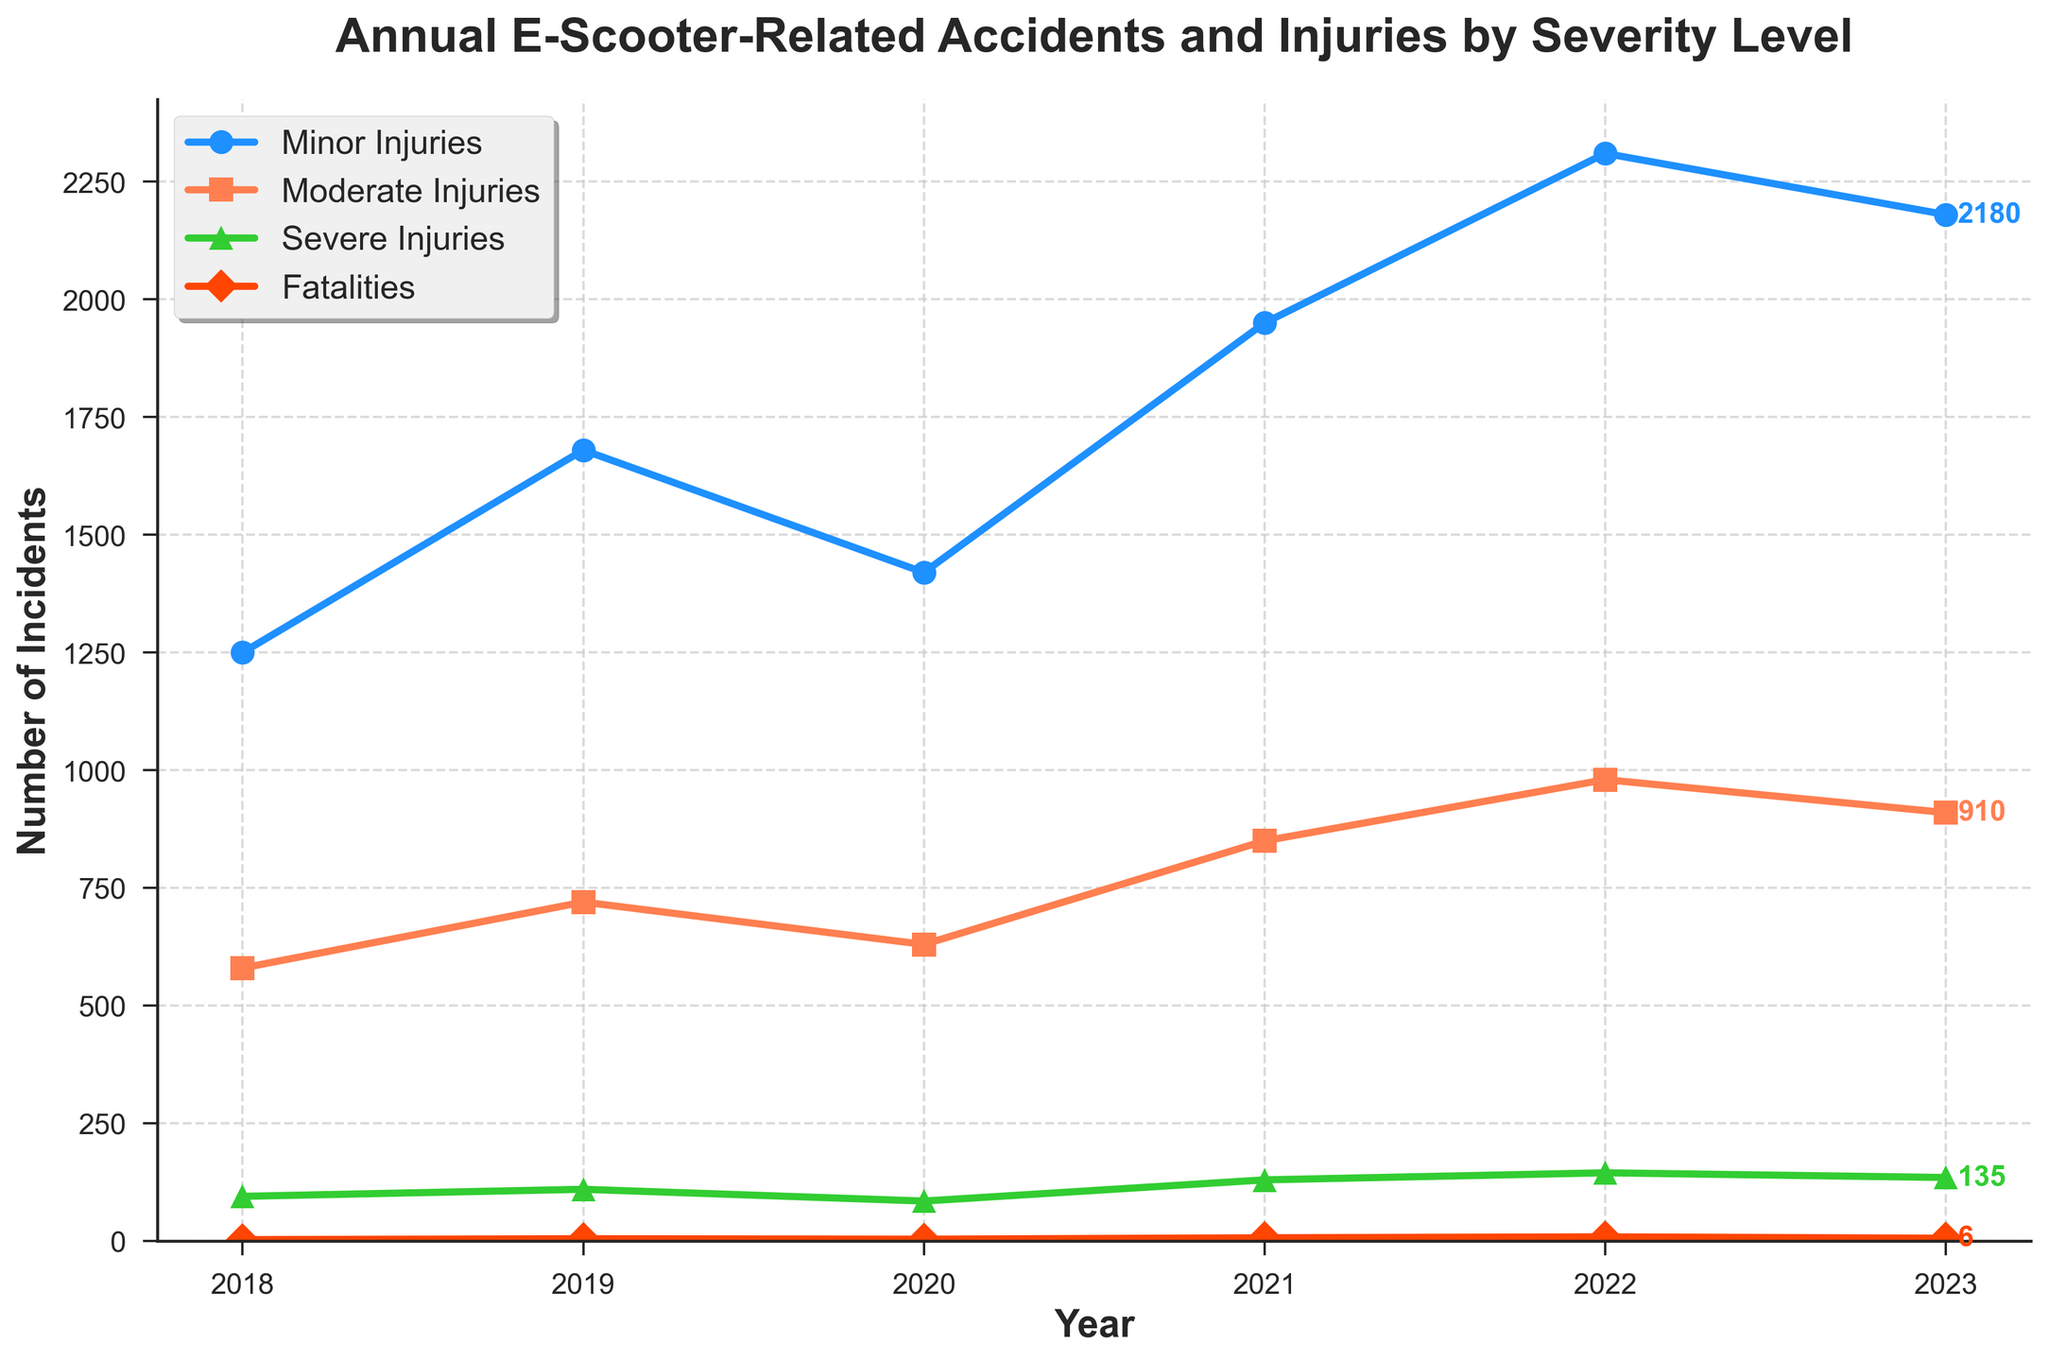What is the trend of Minor Injuries from 2018 to 2023? The figure shows a generally increasing trend in Minor Injuries from 1250 in 2018 to 2310 in 2022, with a slight decrease to 2180 in 2023.
Answer: Increasing, then decreasing in 2023 Which year saw the highest number of Severe Injuries? From the figure, the highest number of Severe Injuries is 145 in 2022.
Answer: 2022 How many total e-scooter-related fatalities were recorded in 2021 and 2022 combined? From the figure, there were 7 fatalities in 2021 and 9 in 2022. Adding these numbers gives us 7 + 9 = 16.
Answer: 16 What is the color used to represent Moderate Injuries? In the figure, the line representing Moderate Injuries is orange in color.
Answer: Orange Which severity level had the most significant increase between 2020 and 2021? Comparing the lines between 2020 and 2021, Minor Injuries increased from 1420 to 1950, a difference of 530; Moderate Injuries increased from 630 to 850, a difference of 220; Severe Injuries rose from 85 to 130, a difference of 45; Fatalities increased from 4 to 7, a difference of 3. The most significant increase is seen in Minor Injuries.
Answer: Minor Injuries How did the number of Minor Injuries change from 2019 to 2023? In 2019, Minor Injuries were 1680, and in 2023, they were 2180. The change is 2180 - 1680 = 500.
Answer: Increased by 500 What was the percentage increase in Fatalities from 2018 to 2023? In 2018, there were 3 Fatalities, and in 2023, there were 6. The percentage increase is ((6 - 3) / 3) * 100% = 100%.
Answer: 100% How does the number of Moderate Injuries in 2022 compare to that in 2018? In 2022, there were 980 Moderate Injuries, while in 2018, there were 580. The difference is 980 - 580 = 400.
Answer: Higher by 400 What is the overall trend in Fatalities from 2018 to 2023? The figure shows a gradual increase in Fatalities from 3 in 2018 to 9 in 2022, with a slight decrease to 6 in 2023.
Answer: Increasing, then decreasing in 2023 What was the combined total of Severe Injuries and Moderate Injuries in 2020? In 2020, Severe Injuries were 85 and Moderate Injuries were 630. Their combined total is 85 + 630 = 715.
Answer: 715 